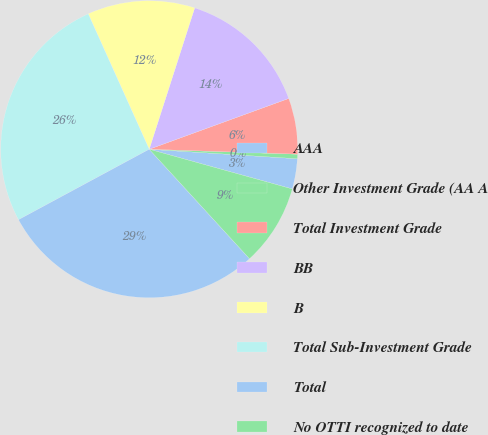Convert chart. <chart><loc_0><loc_0><loc_500><loc_500><pie_chart><fcel>AAA<fcel>Other Investment Grade (AA A<fcel>Total Investment Grade<fcel>BB<fcel>B<fcel>Total Sub-Investment Grade<fcel>Total<fcel>No OTTI recognized to date<nl><fcel>3.29%<fcel>0.49%<fcel>6.09%<fcel>14.49%<fcel>11.69%<fcel>26.14%<fcel>28.94%<fcel>8.89%<nl></chart> 